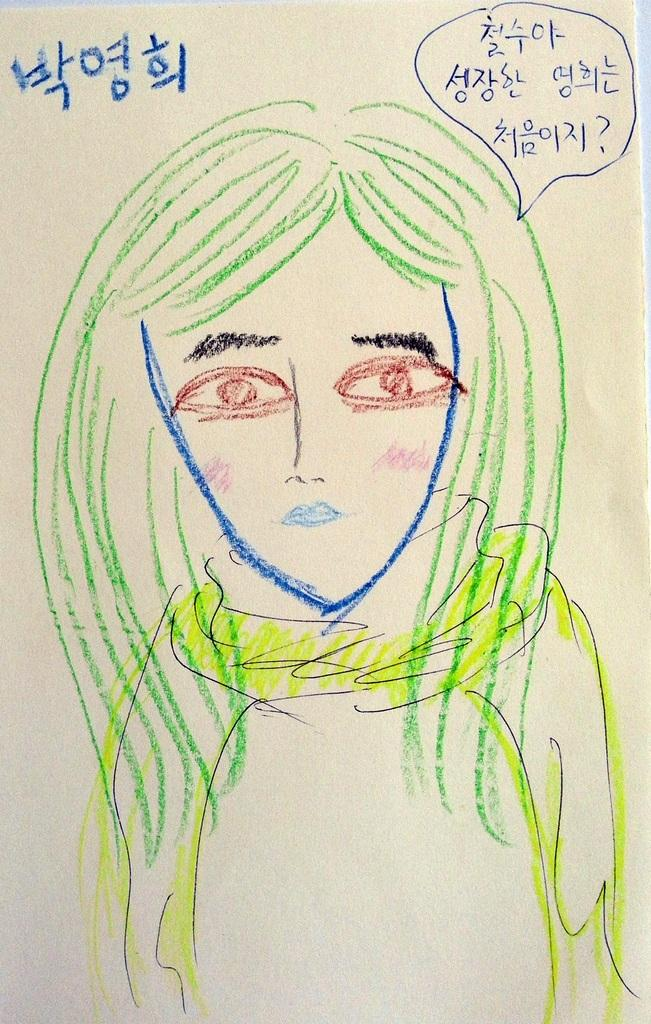What is present in the image that is related to paper? There is a paper in the image. What is on the paper? The paper contains an art piece. What does the art piece depict? The art piece depicts a person. How many stars can be seen in the art piece on the paper? There are no stars visible in the art piece on the paper; it depicts a person. What type of mask is the grandmother wearing in the image? There is no grandmother or mask present in the image; it contains an art piece depicting a person. 